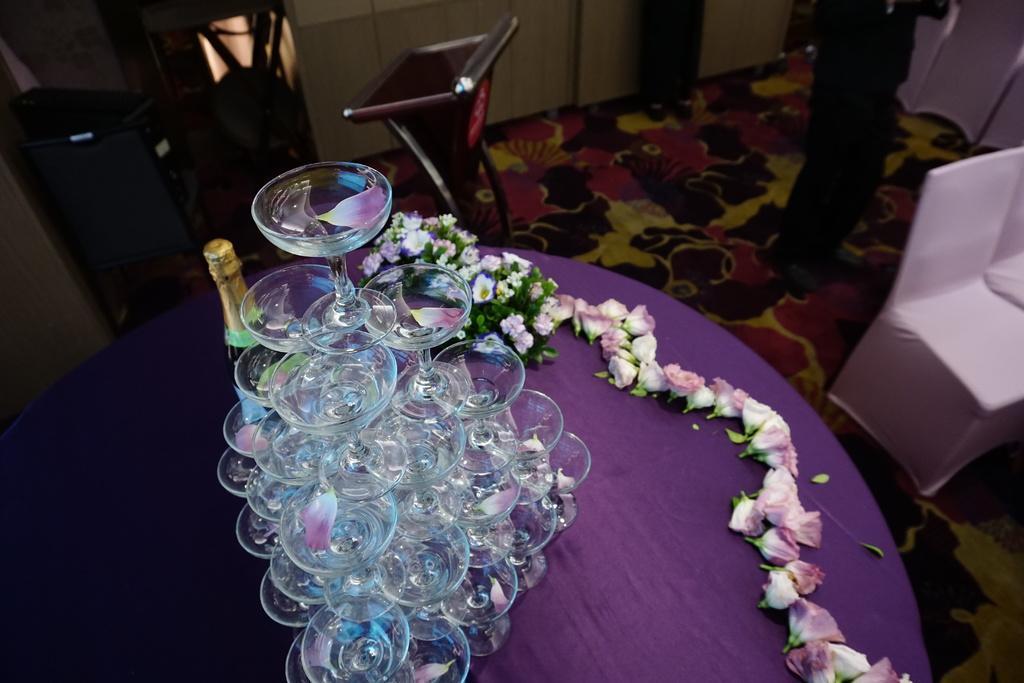In one or two sentences, can you explain what this image depicts? In this image there are glasses on the table and there are flowers and there is a bottle. On the right side there are empty chairs and there is a person standing. In the background there are objects which are black in colour and there is a stand and there is a cupboard. 